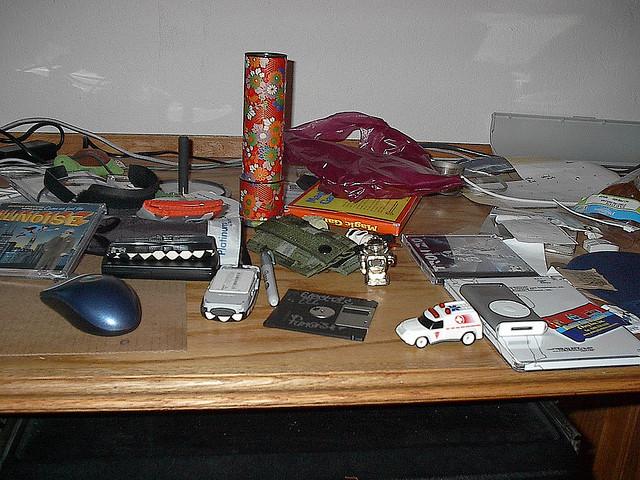Is there a mouse on the desk?
Be succinct. Yes. Is the desk clean?
Give a very brief answer. No. Does the floppy disk have writing on it?
Answer briefly. Yes. What video game is sitting on the desk?
Give a very brief answer. Illinois. 